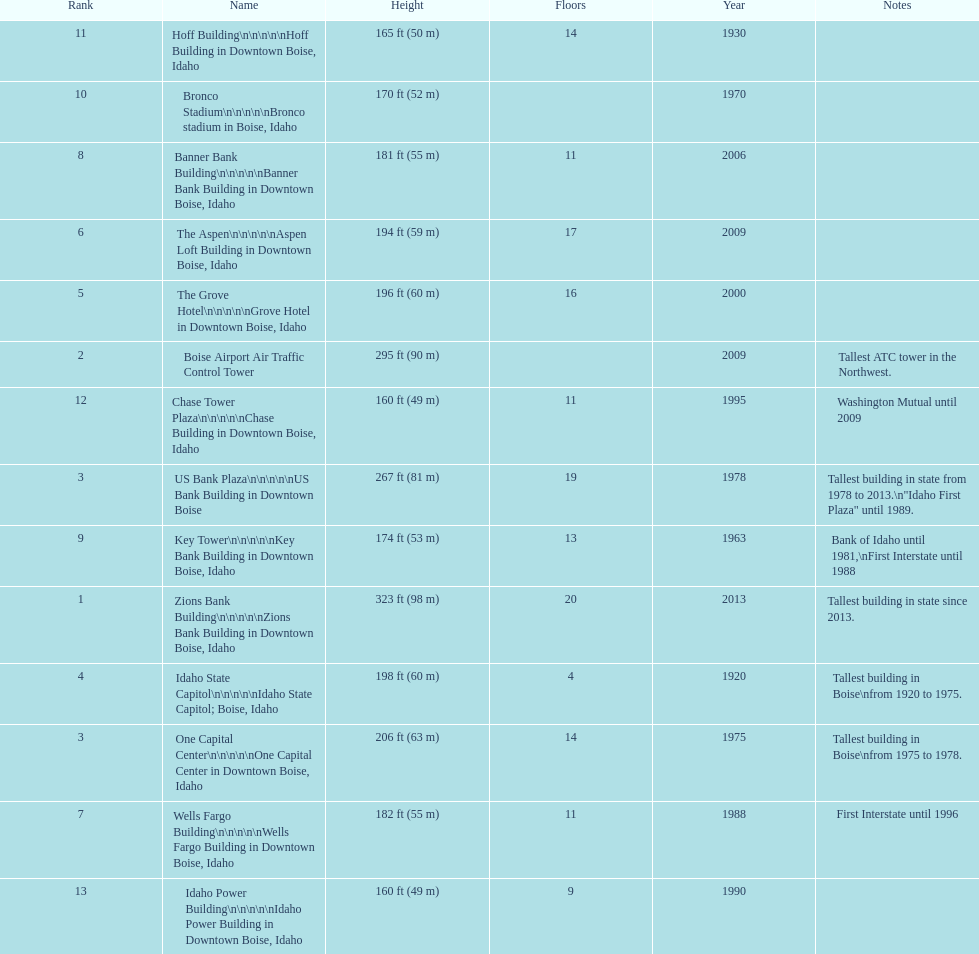Parse the full table. {'header': ['Rank', 'Name', 'Height', 'Floors', 'Year', 'Notes'], 'rows': [['11', 'Hoff Building\\n\\n\\n\\n\\nHoff Building in Downtown Boise, Idaho', '165\xa0ft (50\xa0m)', '14', '1930', ''], ['10', 'Bronco Stadium\\n\\n\\n\\n\\nBronco stadium in Boise, Idaho', '170\xa0ft (52\xa0m)', '', '1970', ''], ['8', 'Banner Bank Building\\n\\n\\n\\n\\nBanner Bank Building in Downtown Boise, Idaho', '181\xa0ft (55\xa0m)', '11', '2006', ''], ['6', 'The Aspen\\n\\n\\n\\n\\nAspen Loft Building in Downtown Boise, Idaho', '194\xa0ft (59\xa0m)', '17', '2009', ''], ['5', 'The Grove Hotel\\n\\n\\n\\n\\nGrove Hotel in Downtown Boise, Idaho', '196\xa0ft (60\xa0m)', '16', '2000', ''], ['2', 'Boise Airport Air Traffic Control Tower', '295\xa0ft (90\xa0m)', '', '2009', 'Tallest ATC tower in the Northwest.'], ['12', 'Chase Tower Plaza\\n\\n\\n\\n\\nChase Building in Downtown Boise, Idaho', '160\xa0ft (49\xa0m)', '11', '1995', 'Washington Mutual until 2009'], ['3', 'US Bank Plaza\\n\\n\\n\\n\\nUS Bank Building in Downtown Boise', '267\xa0ft (81\xa0m)', '19', '1978', 'Tallest building in state from 1978 to 2013.\\n"Idaho First Plaza" until 1989.'], ['9', 'Key Tower\\n\\n\\n\\n\\nKey Bank Building in Downtown Boise, Idaho', '174\xa0ft (53\xa0m)', '13', '1963', 'Bank of Idaho until 1981,\\nFirst Interstate until 1988'], ['1', 'Zions Bank Building\\n\\n\\n\\n\\nZions Bank Building in Downtown Boise, Idaho', '323\xa0ft (98\xa0m)', '20', '2013', 'Tallest building in state since 2013.'], ['4', 'Idaho State Capitol\\n\\n\\n\\n\\nIdaho State Capitol; Boise, Idaho', '198\xa0ft (60\xa0m)', '4', '1920', 'Tallest building in Boise\\nfrom 1920 to 1975.'], ['3', 'One Capital Center\\n\\n\\n\\n\\nOne Capital Center in Downtown Boise, Idaho', '206\xa0ft (63\xa0m)', '14', '1975', 'Tallest building in Boise\\nfrom 1975 to 1978.'], ['7', 'Wells Fargo Building\\n\\n\\n\\n\\nWells Fargo Building in Downtown Boise, Idaho', '182\xa0ft (55\xa0m)', '11', '1988', 'First Interstate until 1996'], ['13', 'Idaho Power Building\\n\\n\\n\\n\\nIdaho Power Building in Downtown Boise, Idaho', '160\xa0ft (49\xa0m)', '9', '1990', '']]} What is the number of floors of the oldest building? 4. 